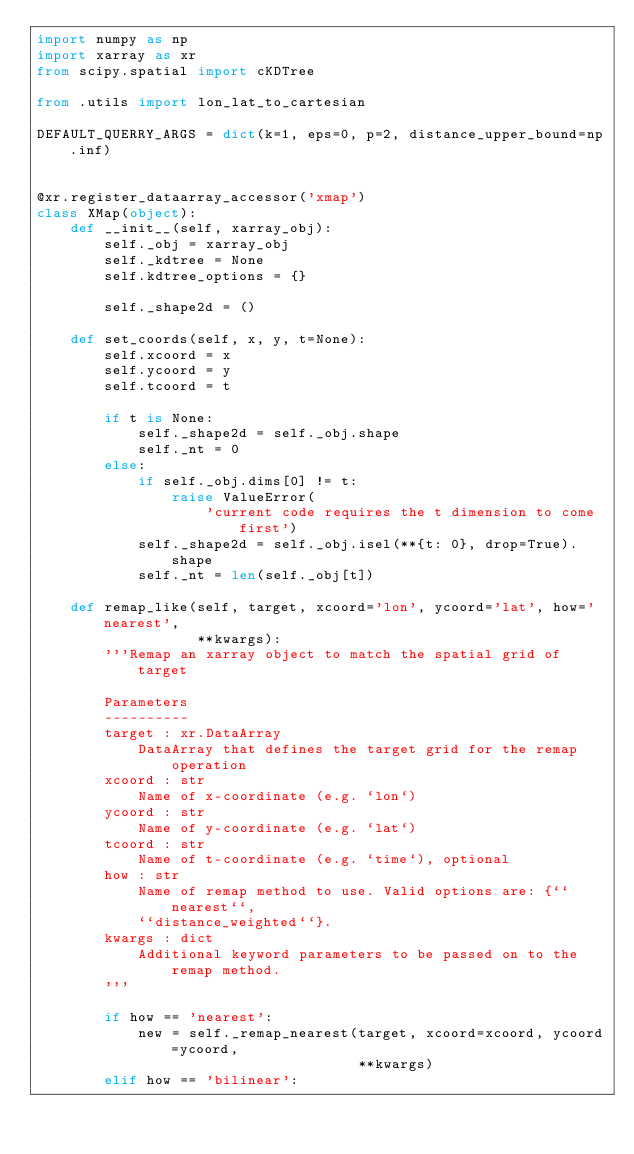Convert code to text. <code><loc_0><loc_0><loc_500><loc_500><_Python_>import numpy as np
import xarray as xr
from scipy.spatial import cKDTree

from .utils import lon_lat_to_cartesian

DEFAULT_QUERRY_ARGS = dict(k=1, eps=0, p=2, distance_upper_bound=np.inf)


@xr.register_dataarray_accessor('xmap')
class XMap(object):
    def __init__(self, xarray_obj):
        self._obj = xarray_obj
        self._kdtree = None
        self.kdtree_options = {}

        self._shape2d = ()

    def set_coords(self, x, y, t=None):
        self.xcoord = x
        self.ycoord = y
        self.tcoord = t

        if t is None:
            self._shape2d = self._obj.shape
            self._nt = 0
        else:
            if self._obj.dims[0] != t:
                raise ValueError(
                    'current code requires the t dimension to come first')
            self._shape2d = self._obj.isel(**{t: 0}, drop=True).shape
            self._nt = len(self._obj[t])

    def remap_like(self, target, xcoord='lon', ycoord='lat', how='nearest',
                   **kwargs):
        '''Remap an xarray object to match the spatial grid of target

        Parameters
        ----------
        target : xr.DataArray
            DataArray that defines the target grid for the remap operation
        xcoord : str
            Name of x-coordinate (e.g. `lon`)
        ycoord : str
            Name of y-coordinate (e.g. `lat`)
        tcoord : str
            Name of t-coordinate (e.g. `time`), optional
        how : str
            Name of remap method to use. Valid options are: {``nearest``,
            ``distance_weighted``}.
        kwargs : dict
            Additional keyword parameters to be passed on to the remap method.
        '''

        if how == 'nearest':
            new = self._remap_nearest(target, xcoord=xcoord, ycoord=ycoord,
                                      **kwargs)
        elif how == 'bilinear':</code> 